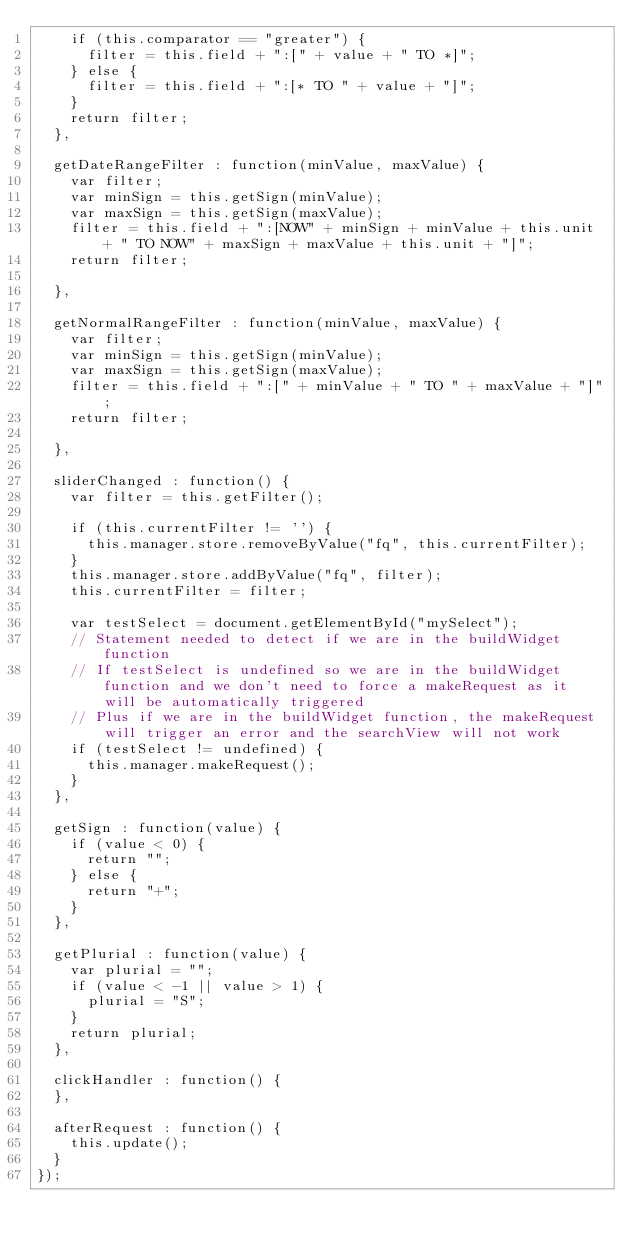Convert code to text. <code><loc_0><loc_0><loc_500><loc_500><_JavaScript_>    if (this.comparator == "greater") {
      filter = this.field + ":[" + value + " TO *]";
    } else {
      filter = this.field + ":[* TO " + value + "]";
    }
    return filter;
  },

  getDateRangeFilter : function(minValue, maxValue) {
    var filter;
    var minSign = this.getSign(minValue);
    var maxSign = this.getSign(maxValue);
    filter = this.field + ":[NOW" + minSign + minValue + this.unit + " TO NOW" + maxSign + maxValue + this.unit + "]";
    return filter;

  },

  getNormalRangeFilter : function(minValue, maxValue) {
    var filter;
    var minSign = this.getSign(minValue);
    var maxSign = this.getSign(maxValue);
    filter = this.field + ":[" + minValue + " TO " + maxValue + "]";
    return filter;

  },

  sliderChanged : function() {
    var filter = this.getFilter();

    if (this.currentFilter != '') {
      this.manager.store.removeByValue("fq", this.currentFilter);
    }
    this.manager.store.addByValue("fq", filter);
    this.currentFilter = filter;

    var testSelect = document.getElementById("mySelect");
    // Statement needed to detect if we are in the buildWidget function
    // If testSelect is undefined so we are in the buildWidget function and we don't need to force a makeRequest as it will be automatically triggered
    // Plus if we are in the buildWidget function, the makeRequest will trigger an error and the searchView will not work
    if (testSelect != undefined) {
      this.manager.makeRequest();
    }
  },

  getSign : function(value) {
    if (value < 0) {
      return "";
    } else {
      return "+";
    }
  },

  getPlurial : function(value) {
    var plurial = "";
    if (value < -1 || value > 1) {
      plurial = "S";
    }
    return plurial;
  },

  clickHandler : function() {
  },

  afterRequest : function() {
    this.update();
  }
});
</code> 